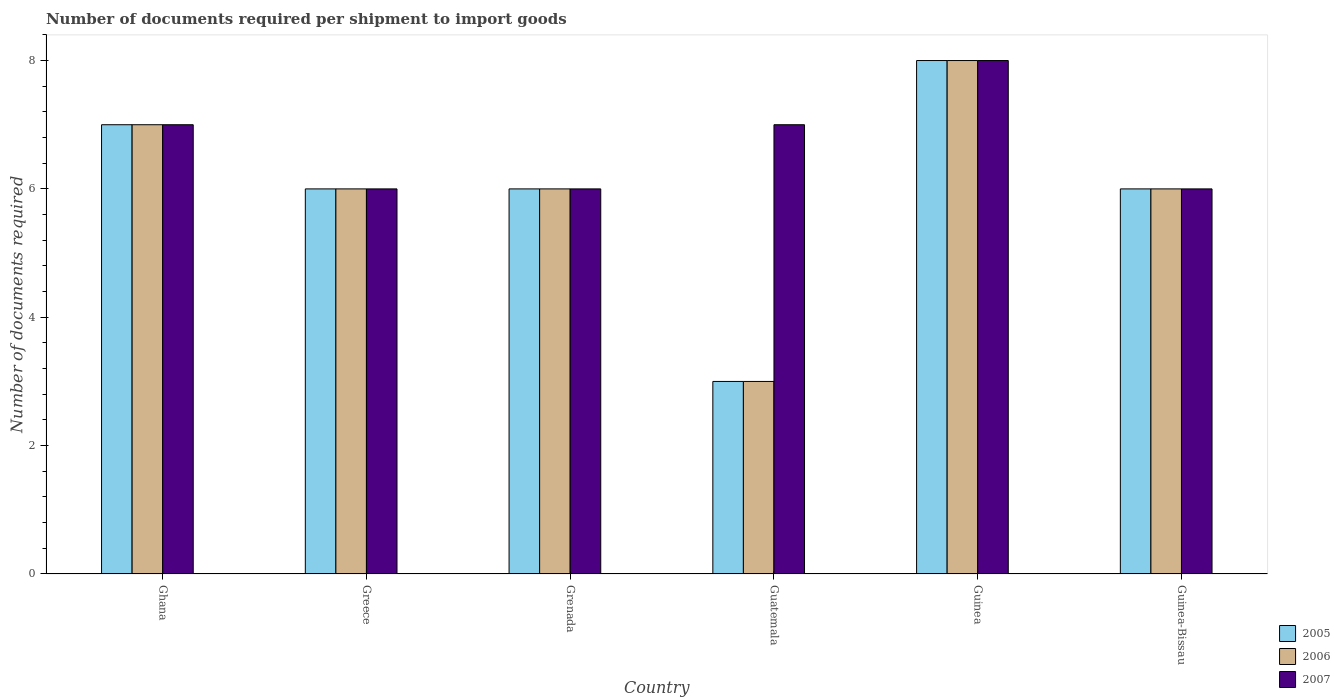How many different coloured bars are there?
Give a very brief answer. 3. What is the label of the 6th group of bars from the left?
Your response must be concise. Guinea-Bissau. What is the number of documents required per shipment to import goods in 2007 in Greece?
Keep it short and to the point. 6. Across all countries, what is the maximum number of documents required per shipment to import goods in 2007?
Give a very brief answer. 8. Across all countries, what is the minimum number of documents required per shipment to import goods in 2007?
Offer a terse response. 6. In which country was the number of documents required per shipment to import goods in 2006 maximum?
Keep it short and to the point. Guinea. In which country was the number of documents required per shipment to import goods in 2006 minimum?
Offer a terse response. Guatemala. What is the total number of documents required per shipment to import goods in 2005 in the graph?
Ensure brevity in your answer.  36. What is the difference between the number of documents required per shipment to import goods of/in 2005 and number of documents required per shipment to import goods of/in 2006 in Greece?
Offer a very short reply. 0. What is the ratio of the number of documents required per shipment to import goods in 2007 in Guatemala to that in Guinea-Bissau?
Offer a terse response. 1.17. Is the number of documents required per shipment to import goods in 2005 in Ghana less than that in Guinea-Bissau?
Your response must be concise. No. Is the difference between the number of documents required per shipment to import goods in 2005 in Ghana and Guinea-Bissau greater than the difference between the number of documents required per shipment to import goods in 2006 in Ghana and Guinea-Bissau?
Make the answer very short. No. What is the difference between the highest and the second highest number of documents required per shipment to import goods in 2006?
Make the answer very short. 2. What is the difference between the highest and the lowest number of documents required per shipment to import goods in 2007?
Offer a terse response. 2. What does the 2nd bar from the left in Greece represents?
Give a very brief answer. 2006. Are all the bars in the graph horizontal?
Your answer should be compact. No. How many countries are there in the graph?
Offer a terse response. 6. What is the difference between two consecutive major ticks on the Y-axis?
Your answer should be compact. 2. Are the values on the major ticks of Y-axis written in scientific E-notation?
Provide a succinct answer. No. Where does the legend appear in the graph?
Provide a succinct answer. Bottom right. How many legend labels are there?
Your answer should be very brief. 3. What is the title of the graph?
Your answer should be compact. Number of documents required per shipment to import goods. Does "1961" appear as one of the legend labels in the graph?
Make the answer very short. No. What is the label or title of the Y-axis?
Keep it short and to the point. Number of documents required. What is the Number of documents required of 2007 in Ghana?
Make the answer very short. 7. What is the Number of documents required in 2005 in Greece?
Offer a terse response. 6. What is the Number of documents required of 2005 in Grenada?
Ensure brevity in your answer.  6. What is the Number of documents required in 2006 in Grenada?
Your response must be concise. 6. What is the Number of documents required of 2006 in Guatemala?
Provide a short and direct response. 3. What is the Number of documents required of 2007 in Guatemala?
Give a very brief answer. 7. What is the Number of documents required in 2006 in Guinea-Bissau?
Ensure brevity in your answer.  6. What is the Number of documents required of 2007 in Guinea-Bissau?
Ensure brevity in your answer.  6. Across all countries, what is the maximum Number of documents required in 2007?
Provide a short and direct response. 8. Across all countries, what is the minimum Number of documents required in 2006?
Your answer should be compact. 3. What is the total Number of documents required in 2006 in the graph?
Your answer should be compact. 36. What is the total Number of documents required in 2007 in the graph?
Your answer should be very brief. 40. What is the difference between the Number of documents required of 2005 in Ghana and that in Greece?
Your answer should be very brief. 1. What is the difference between the Number of documents required in 2007 in Ghana and that in Greece?
Provide a succinct answer. 1. What is the difference between the Number of documents required of 2005 in Ghana and that in Grenada?
Your response must be concise. 1. What is the difference between the Number of documents required in 2006 in Ghana and that in Grenada?
Give a very brief answer. 1. What is the difference between the Number of documents required in 2007 in Ghana and that in Grenada?
Ensure brevity in your answer.  1. What is the difference between the Number of documents required of 2006 in Ghana and that in Guatemala?
Offer a very short reply. 4. What is the difference between the Number of documents required in 2007 in Ghana and that in Guatemala?
Make the answer very short. 0. What is the difference between the Number of documents required of 2005 in Ghana and that in Guinea?
Provide a short and direct response. -1. What is the difference between the Number of documents required in 2006 in Ghana and that in Guinea?
Make the answer very short. -1. What is the difference between the Number of documents required of 2007 in Ghana and that in Guinea?
Offer a terse response. -1. What is the difference between the Number of documents required in 2005 in Ghana and that in Guinea-Bissau?
Keep it short and to the point. 1. What is the difference between the Number of documents required in 2007 in Ghana and that in Guinea-Bissau?
Offer a very short reply. 1. What is the difference between the Number of documents required of 2006 in Greece and that in Grenada?
Your answer should be compact. 0. What is the difference between the Number of documents required of 2005 in Greece and that in Guatemala?
Your answer should be compact. 3. What is the difference between the Number of documents required in 2006 in Greece and that in Guatemala?
Ensure brevity in your answer.  3. What is the difference between the Number of documents required of 2007 in Greece and that in Guatemala?
Provide a short and direct response. -1. What is the difference between the Number of documents required in 2007 in Greece and that in Guinea?
Provide a short and direct response. -2. What is the difference between the Number of documents required in 2006 in Greece and that in Guinea-Bissau?
Ensure brevity in your answer.  0. What is the difference between the Number of documents required in 2006 in Grenada and that in Guatemala?
Provide a short and direct response. 3. What is the difference between the Number of documents required in 2007 in Grenada and that in Guatemala?
Your answer should be very brief. -1. What is the difference between the Number of documents required of 2006 in Grenada and that in Guinea?
Provide a short and direct response. -2. What is the difference between the Number of documents required in 2007 in Grenada and that in Guinea?
Your answer should be very brief. -2. What is the difference between the Number of documents required of 2006 in Grenada and that in Guinea-Bissau?
Your response must be concise. 0. What is the difference between the Number of documents required in 2005 in Guatemala and that in Guinea?
Your answer should be very brief. -5. What is the difference between the Number of documents required of 2007 in Guatemala and that in Guinea?
Your answer should be very brief. -1. What is the difference between the Number of documents required of 2007 in Guatemala and that in Guinea-Bissau?
Ensure brevity in your answer.  1. What is the difference between the Number of documents required of 2005 in Ghana and the Number of documents required of 2006 in Greece?
Provide a succinct answer. 1. What is the difference between the Number of documents required in 2006 in Ghana and the Number of documents required in 2007 in Greece?
Ensure brevity in your answer.  1. What is the difference between the Number of documents required of 2005 in Ghana and the Number of documents required of 2007 in Grenada?
Your answer should be compact. 1. What is the difference between the Number of documents required in 2005 in Ghana and the Number of documents required in 2006 in Guinea?
Provide a short and direct response. -1. What is the difference between the Number of documents required in 2005 in Ghana and the Number of documents required in 2007 in Guinea?
Give a very brief answer. -1. What is the difference between the Number of documents required of 2006 in Ghana and the Number of documents required of 2007 in Guinea?
Your response must be concise. -1. What is the difference between the Number of documents required of 2005 in Greece and the Number of documents required of 2006 in Grenada?
Give a very brief answer. 0. What is the difference between the Number of documents required of 2006 in Greece and the Number of documents required of 2007 in Grenada?
Keep it short and to the point. 0. What is the difference between the Number of documents required in 2005 in Greece and the Number of documents required in 2006 in Guatemala?
Your answer should be very brief. 3. What is the difference between the Number of documents required of 2006 in Greece and the Number of documents required of 2007 in Guatemala?
Your answer should be compact. -1. What is the difference between the Number of documents required in 2005 in Greece and the Number of documents required in 2007 in Guinea?
Keep it short and to the point. -2. What is the difference between the Number of documents required in 2006 in Greece and the Number of documents required in 2007 in Guinea?
Keep it short and to the point. -2. What is the difference between the Number of documents required in 2005 in Grenada and the Number of documents required in 2006 in Guatemala?
Provide a short and direct response. 3. What is the difference between the Number of documents required in 2005 in Grenada and the Number of documents required in 2007 in Guinea?
Give a very brief answer. -2. What is the difference between the Number of documents required in 2005 in Grenada and the Number of documents required in 2007 in Guinea-Bissau?
Your response must be concise. 0. What is the difference between the Number of documents required of 2006 in Grenada and the Number of documents required of 2007 in Guinea-Bissau?
Your response must be concise. 0. What is the difference between the Number of documents required of 2005 in Guinea and the Number of documents required of 2006 in Guinea-Bissau?
Your answer should be very brief. 2. What is the difference between the Number of documents required of 2006 in Guinea and the Number of documents required of 2007 in Guinea-Bissau?
Ensure brevity in your answer.  2. What is the average Number of documents required in 2005 per country?
Your answer should be compact. 6. What is the average Number of documents required of 2006 per country?
Your answer should be very brief. 6. What is the average Number of documents required in 2007 per country?
Your response must be concise. 6.67. What is the difference between the Number of documents required in 2005 and Number of documents required in 2006 in Ghana?
Offer a very short reply. 0. What is the difference between the Number of documents required in 2005 and Number of documents required in 2007 in Ghana?
Give a very brief answer. 0. What is the difference between the Number of documents required in 2006 and Number of documents required in 2007 in Ghana?
Keep it short and to the point. 0. What is the difference between the Number of documents required of 2005 and Number of documents required of 2006 in Greece?
Your answer should be very brief. 0. What is the difference between the Number of documents required of 2006 and Number of documents required of 2007 in Greece?
Provide a short and direct response. 0. What is the difference between the Number of documents required in 2005 and Number of documents required in 2006 in Grenada?
Your answer should be compact. 0. What is the difference between the Number of documents required of 2006 and Number of documents required of 2007 in Grenada?
Provide a succinct answer. 0. What is the difference between the Number of documents required of 2005 and Number of documents required of 2006 in Guatemala?
Your response must be concise. 0. What is the difference between the Number of documents required of 2005 and Number of documents required of 2007 in Guatemala?
Give a very brief answer. -4. What is the difference between the Number of documents required of 2006 and Number of documents required of 2007 in Guinea?
Provide a short and direct response. 0. What is the difference between the Number of documents required of 2005 and Number of documents required of 2007 in Guinea-Bissau?
Your answer should be compact. 0. What is the difference between the Number of documents required in 2006 and Number of documents required in 2007 in Guinea-Bissau?
Offer a terse response. 0. What is the ratio of the Number of documents required of 2005 in Ghana to that in Greece?
Give a very brief answer. 1.17. What is the ratio of the Number of documents required in 2006 in Ghana to that in Grenada?
Provide a succinct answer. 1.17. What is the ratio of the Number of documents required of 2005 in Ghana to that in Guatemala?
Your answer should be compact. 2.33. What is the ratio of the Number of documents required of 2006 in Ghana to that in Guatemala?
Give a very brief answer. 2.33. What is the ratio of the Number of documents required of 2007 in Ghana to that in Guatemala?
Keep it short and to the point. 1. What is the ratio of the Number of documents required in 2005 in Ghana to that in Guinea?
Make the answer very short. 0.88. What is the ratio of the Number of documents required of 2006 in Ghana to that in Guinea?
Offer a terse response. 0.88. What is the ratio of the Number of documents required in 2005 in Ghana to that in Guinea-Bissau?
Provide a succinct answer. 1.17. What is the ratio of the Number of documents required in 2006 in Ghana to that in Guinea-Bissau?
Provide a succinct answer. 1.17. What is the ratio of the Number of documents required in 2007 in Greece to that in Guatemala?
Provide a succinct answer. 0.86. What is the ratio of the Number of documents required in 2005 in Greece to that in Guinea?
Ensure brevity in your answer.  0.75. What is the ratio of the Number of documents required in 2007 in Greece to that in Guinea?
Your answer should be compact. 0.75. What is the ratio of the Number of documents required in 2005 in Greece to that in Guinea-Bissau?
Make the answer very short. 1. What is the ratio of the Number of documents required in 2006 in Grenada to that in Guatemala?
Ensure brevity in your answer.  2. What is the ratio of the Number of documents required of 2005 in Grenada to that in Guinea-Bissau?
Offer a very short reply. 1. What is the ratio of the Number of documents required in 2007 in Grenada to that in Guinea-Bissau?
Offer a very short reply. 1. What is the ratio of the Number of documents required in 2006 in Guatemala to that in Guinea?
Your response must be concise. 0.38. What is the ratio of the Number of documents required of 2007 in Guatemala to that in Guinea?
Provide a short and direct response. 0.88. What is the ratio of the Number of documents required of 2005 in Guatemala to that in Guinea-Bissau?
Provide a succinct answer. 0.5. What is the ratio of the Number of documents required of 2006 in Guatemala to that in Guinea-Bissau?
Provide a short and direct response. 0.5. What is the ratio of the Number of documents required in 2005 in Guinea to that in Guinea-Bissau?
Your response must be concise. 1.33. What is the ratio of the Number of documents required of 2006 in Guinea to that in Guinea-Bissau?
Keep it short and to the point. 1.33. What is the difference between the highest and the second highest Number of documents required of 2005?
Keep it short and to the point. 1. What is the difference between the highest and the second highest Number of documents required in 2006?
Offer a terse response. 1. What is the difference between the highest and the second highest Number of documents required of 2007?
Ensure brevity in your answer.  1. What is the difference between the highest and the lowest Number of documents required of 2007?
Ensure brevity in your answer.  2. 